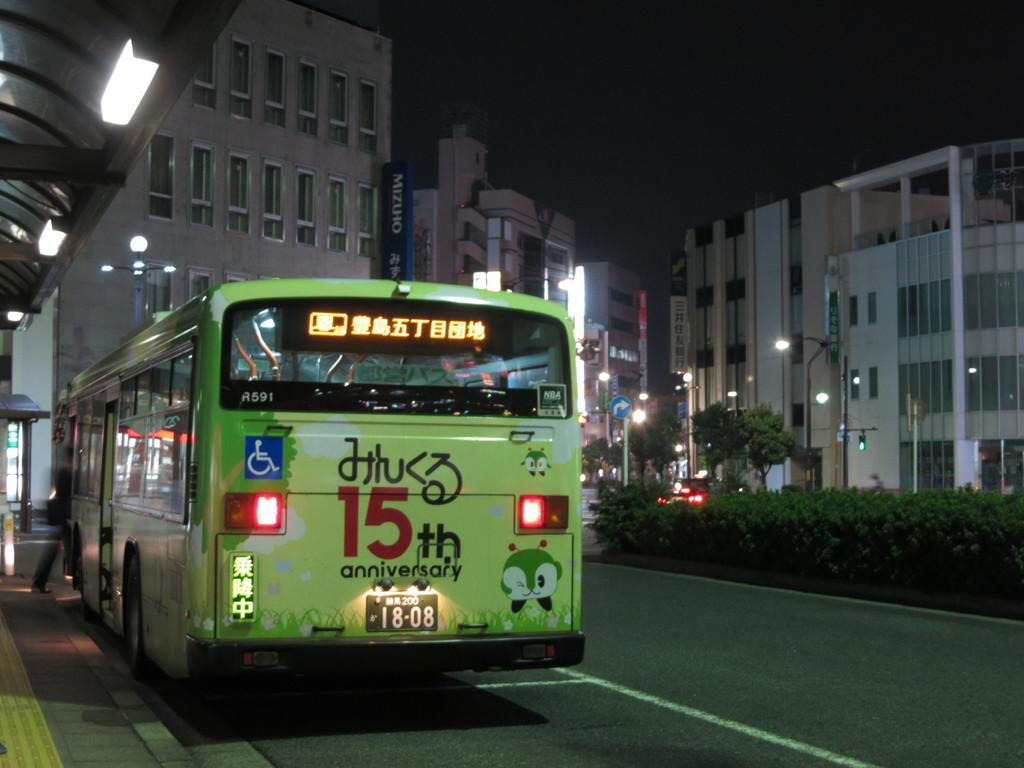Provide a one-sentence caption for the provided image. A green bus with a 15th anniversary sign on it is on the road. 